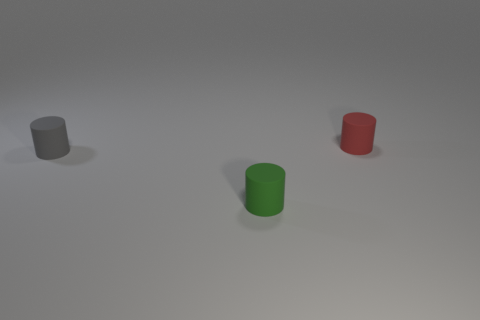Are the green cylinder and the small cylinder left of the green matte object made of the same material?
Offer a terse response. Yes. What number of other objects are the same shape as the tiny gray rubber object?
Your answer should be very brief. 2. What number of objects are either gray cylinders behind the small green rubber thing or small matte cylinders on the right side of the gray object?
Your response must be concise. 3. Are there fewer tiny gray things that are on the left side of the small green cylinder than red things that are left of the red matte thing?
Offer a terse response. No. What number of small purple shiny balls are there?
Provide a succinct answer. 0. Are there any other things that have the same material as the tiny green object?
Ensure brevity in your answer.  Yes. There is a green object that is the same shape as the gray rubber thing; what is it made of?
Give a very brief answer. Rubber. Are there fewer green cylinders to the right of the red matte object than small objects?
Offer a terse response. Yes. Does the small thing behind the small gray object have the same shape as the tiny green object?
Provide a succinct answer. Yes. The green cylinder that is the same material as the tiny gray object is what size?
Ensure brevity in your answer.  Small. 